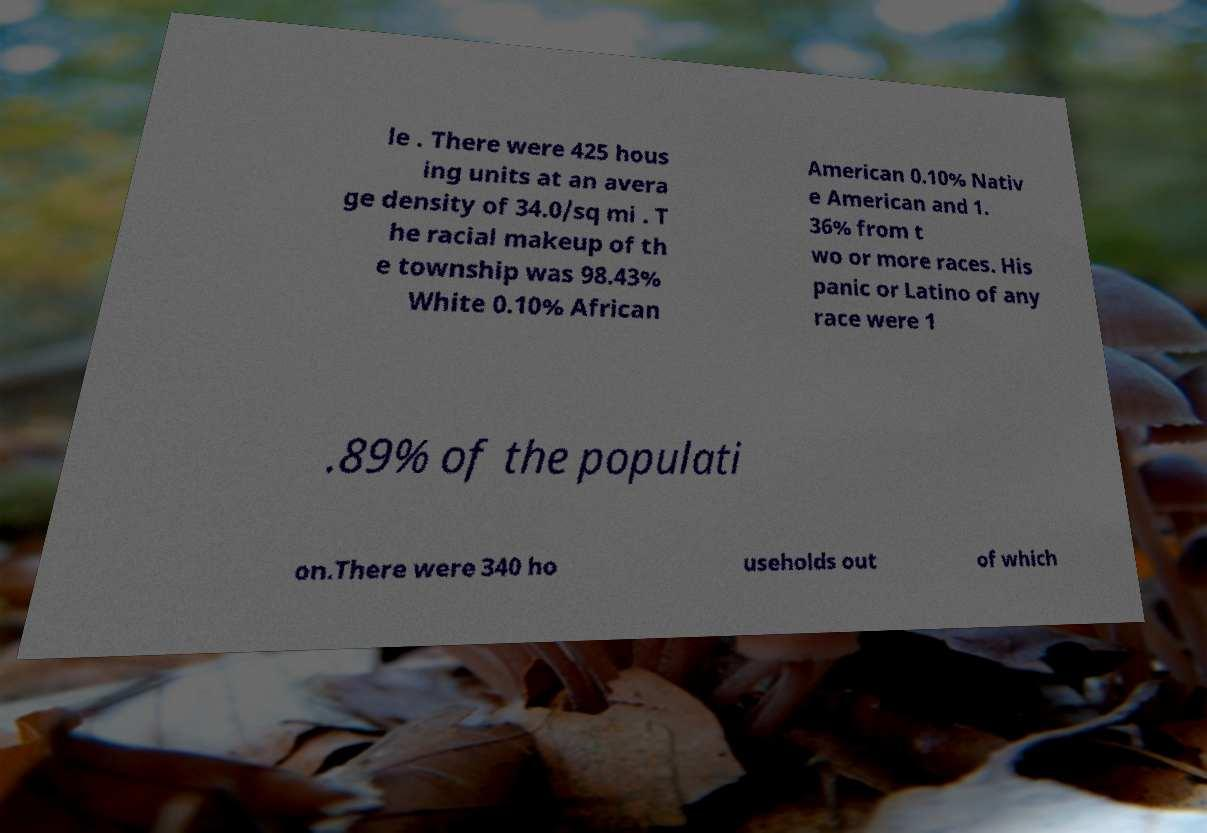Can you read and provide the text displayed in the image?This photo seems to have some interesting text. Can you extract and type it out for me? le . There were 425 hous ing units at an avera ge density of 34.0/sq mi . T he racial makeup of th e township was 98.43% White 0.10% African American 0.10% Nativ e American and 1. 36% from t wo or more races. His panic or Latino of any race were 1 .89% of the populati on.There were 340 ho useholds out of which 